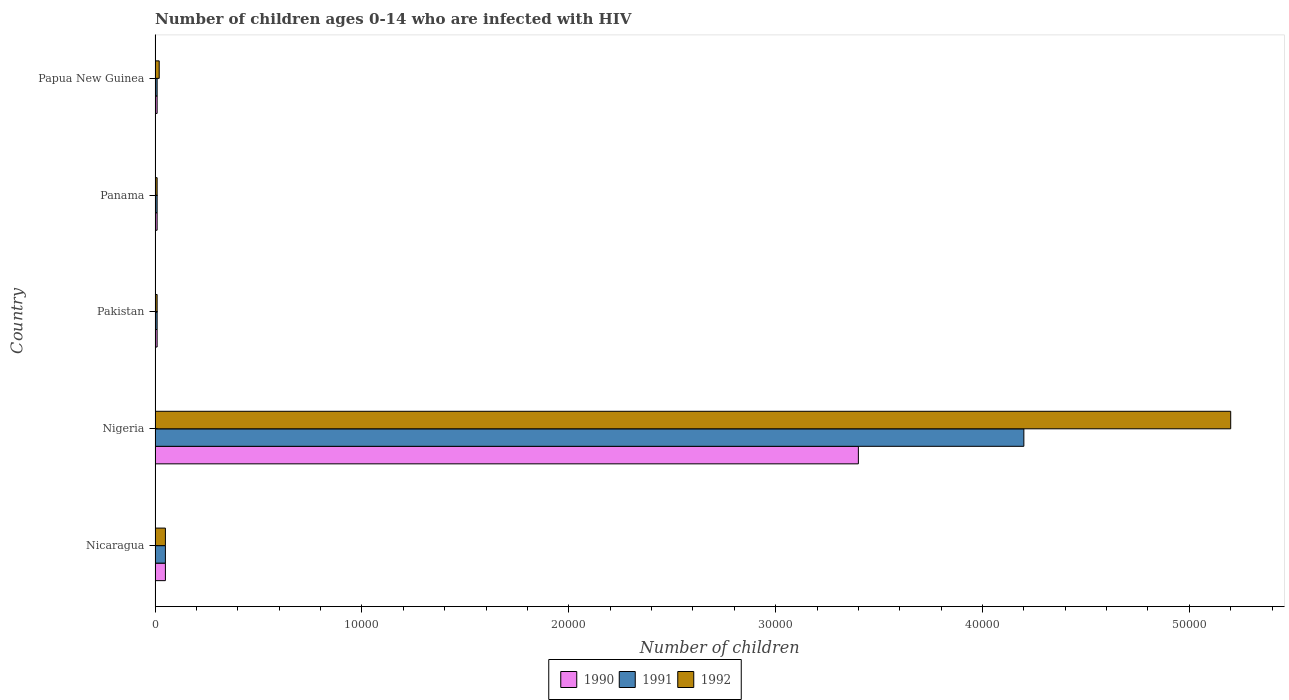Are the number of bars on each tick of the Y-axis equal?
Offer a terse response. Yes. How many bars are there on the 5th tick from the bottom?
Offer a very short reply. 3. What is the label of the 1st group of bars from the top?
Your answer should be compact. Papua New Guinea. What is the number of HIV infected children in 1992 in Panama?
Offer a terse response. 100. Across all countries, what is the maximum number of HIV infected children in 1992?
Your response must be concise. 5.20e+04. Across all countries, what is the minimum number of HIV infected children in 1990?
Your answer should be very brief. 100. In which country was the number of HIV infected children in 1990 maximum?
Provide a short and direct response. Nigeria. In which country was the number of HIV infected children in 1992 minimum?
Offer a terse response. Pakistan. What is the total number of HIV infected children in 1992 in the graph?
Your answer should be compact. 5.29e+04. What is the difference between the number of HIV infected children in 1991 in Nicaragua and that in Nigeria?
Keep it short and to the point. -4.15e+04. What is the difference between the number of HIV infected children in 1991 in Nicaragua and the number of HIV infected children in 1990 in Panama?
Offer a very short reply. 400. What is the average number of HIV infected children in 1991 per country?
Ensure brevity in your answer.  8560. What is the difference between the number of HIV infected children in 1992 and number of HIV infected children in 1991 in Nicaragua?
Ensure brevity in your answer.  0. In how many countries, is the number of HIV infected children in 1990 greater than 32000 ?
Keep it short and to the point. 1. What is the difference between the highest and the second highest number of HIV infected children in 1990?
Give a very brief answer. 3.35e+04. What is the difference between the highest and the lowest number of HIV infected children in 1992?
Keep it short and to the point. 5.19e+04. Is the sum of the number of HIV infected children in 1990 in Nicaragua and Pakistan greater than the maximum number of HIV infected children in 1991 across all countries?
Ensure brevity in your answer.  No. What does the 1st bar from the top in Nigeria represents?
Provide a short and direct response. 1992. What does the 2nd bar from the bottom in Papua New Guinea represents?
Provide a succinct answer. 1991. Is it the case that in every country, the sum of the number of HIV infected children in 1992 and number of HIV infected children in 1990 is greater than the number of HIV infected children in 1991?
Provide a succinct answer. Yes. How many countries are there in the graph?
Your response must be concise. 5. What is the difference between two consecutive major ticks on the X-axis?
Your answer should be compact. 10000. Are the values on the major ticks of X-axis written in scientific E-notation?
Provide a short and direct response. No. Does the graph contain any zero values?
Your response must be concise. No. Does the graph contain grids?
Keep it short and to the point. No. How many legend labels are there?
Give a very brief answer. 3. What is the title of the graph?
Provide a short and direct response. Number of children ages 0-14 who are infected with HIV. Does "2015" appear as one of the legend labels in the graph?
Your answer should be very brief. No. What is the label or title of the X-axis?
Offer a very short reply. Number of children. What is the label or title of the Y-axis?
Provide a succinct answer. Country. What is the Number of children of 1990 in Nicaragua?
Offer a very short reply. 500. What is the Number of children in 1991 in Nicaragua?
Keep it short and to the point. 500. What is the Number of children of 1990 in Nigeria?
Make the answer very short. 3.40e+04. What is the Number of children in 1991 in Nigeria?
Your answer should be very brief. 4.20e+04. What is the Number of children of 1992 in Nigeria?
Give a very brief answer. 5.20e+04. What is the Number of children of 1992 in Pakistan?
Provide a succinct answer. 100. What is the Number of children in 1991 in Panama?
Ensure brevity in your answer.  100. What is the Number of children of 1992 in Panama?
Give a very brief answer. 100. What is the Number of children in 1990 in Papua New Guinea?
Offer a very short reply. 100. What is the Number of children in 1992 in Papua New Guinea?
Give a very brief answer. 200. Across all countries, what is the maximum Number of children in 1990?
Give a very brief answer. 3.40e+04. Across all countries, what is the maximum Number of children of 1991?
Provide a succinct answer. 4.20e+04. Across all countries, what is the maximum Number of children in 1992?
Offer a terse response. 5.20e+04. Across all countries, what is the minimum Number of children in 1992?
Keep it short and to the point. 100. What is the total Number of children in 1990 in the graph?
Keep it short and to the point. 3.48e+04. What is the total Number of children of 1991 in the graph?
Offer a very short reply. 4.28e+04. What is the total Number of children in 1992 in the graph?
Provide a short and direct response. 5.29e+04. What is the difference between the Number of children in 1990 in Nicaragua and that in Nigeria?
Offer a very short reply. -3.35e+04. What is the difference between the Number of children in 1991 in Nicaragua and that in Nigeria?
Make the answer very short. -4.15e+04. What is the difference between the Number of children of 1992 in Nicaragua and that in Nigeria?
Provide a succinct answer. -5.15e+04. What is the difference between the Number of children in 1991 in Nicaragua and that in Panama?
Your response must be concise. 400. What is the difference between the Number of children of 1992 in Nicaragua and that in Panama?
Give a very brief answer. 400. What is the difference between the Number of children in 1990 in Nicaragua and that in Papua New Guinea?
Offer a terse response. 400. What is the difference between the Number of children in 1991 in Nicaragua and that in Papua New Guinea?
Offer a very short reply. 400. What is the difference between the Number of children of 1992 in Nicaragua and that in Papua New Guinea?
Provide a short and direct response. 300. What is the difference between the Number of children in 1990 in Nigeria and that in Pakistan?
Offer a very short reply. 3.39e+04. What is the difference between the Number of children of 1991 in Nigeria and that in Pakistan?
Provide a short and direct response. 4.19e+04. What is the difference between the Number of children in 1992 in Nigeria and that in Pakistan?
Offer a terse response. 5.19e+04. What is the difference between the Number of children in 1990 in Nigeria and that in Panama?
Provide a short and direct response. 3.39e+04. What is the difference between the Number of children in 1991 in Nigeria and that in Panama?
Make the answer very short. 4.19e+04. What is the difference between the Number of children in 1992 in Nigeria and that in Panama?
Offer a very short reply. 5.19e+04. What is the difference between the Number of children of 1990 in Nigeria and that in Papua New Guinea?
Your answer should be very brief. 3.39e+04. What is the difference between the Number of children in 1991 in Nigeria and that in Papua New Guinea?
Ensure brevity in your answer.  4.19e+04. What is the difference between the Number of children of 1992 in Nigeria and that in Papua New Guinea?
Your answer should be very brief. 5.18e+04. What is the difference between the Number of children in 1991 in Pakistan and that in Panama?
Offer a very short reply. 0. What is the difference between the Number of children in 1991 in Pakistan and that in Papua New Guinea?
Ensure brevity in your answer.  0. What is the difference between the Number of children of 1992 in Pakistan and that in Papua New Guinea?
Ensure brevity in your answer.  -100. What is the difference between the Number of children in 1990 in Panama and that in Papua New Guinea?
Your answer should be compact. 0. What is the difference between the Number of children in 1991 in Panama and that in Papua New Guinea?
Offer a very short reply. 0. What is the difference between the Number of children of 1992 in Panama and that in Papua New Guinea?
Keep it short and to the point. -100. What is the difference between the Number of children in 1990 in Nicaragua and the Number of children in 1991 in Nigeria?
Provide a short and direct response. -4.15e+04. What is the difference between the Number of children in 1990 in Nicaragua and the Number of children in 1992 in Nigeria?
Your response must be concise. -5.15e+04. What is the difference between the Number of children in 1991 in Nicaragua and the Number of children in 1992 in Nigeria?
Provide a succinct answer. -5.15e+04. What is the difference between the Number of children in 1990 in Nicaragua and the Number of children in 1991 in Pakistan?
Make the answer very short. 400. What is the difference between the Number of children in 1990 in Nicaragua and the Number of children in 1992 in Pakistan?
Your answer should be compact. 400. What is the difference between the Number of children of 1990 in Nicaragua and the Number of children of 1992 in Papua New Guinea?
Keep it short and to the point. 300. What is the difference between the Number of children in 1991 in Nicaragua and the Number of children in 1992 in Papua New Guinea?
Ensure brevity in your answer.  300. What is the difference between the Number of children in 1990 in Nigeria and the Number of children in 1991 in Pakistan?
Ensure brevity in your answer.  3.39e+04. What is the difference between the Number of children of 1990 in Nigeria and the Number of children of 1992 in Pakistan?
Your answer should be compact. 3.39e+04. What is the difference between the Number of children of 1991 in Nigeria and the Number of children of 1992 in Pakistan?
Make the answer very short. 4.19e+04. What is the difference between the Number of children in 1990 in Nigeria and the Number of children in 1991 in Panama?
Your answer should be very brief. 3.39e+04. What is the difference between the Number of children in 1990 in Nigeria and the Number of children in 1992 in Panama?
Make the answer very short. 3.39e+04. What is the difference between the Number of children of 1991 in Nigeria and the Number of children of 1992 in Panama?
Provide a succinct answer. 4.19e+04. What is the difference between the Number of children of 1990 in Nigeria and the Number of children of 1991 in Papua New Guinea?
Your answer should be very brief. 3.39e+04. What is the difference between the Number of children in 1990 in Nigeria and the Number of children in 1992 in Papua New Guinea?
Your answer should be compact. 3.38e+04. What is the difference between the Number of children of 1991 in Nigeria and the Number of children of 1992 in Papua New Guinea?
Keep it short and to the point. 4.18e+04. What is the difference between the Number of children of 1991 in Pakistan and the Number of children of 1992 in Panama?
Your response must be concise. 0. What is the difference between the Number of children in 1990 in Pakistan and the Number of children in 1992 in Papua New Guinea?
Offer a very short reply. -100. What is the difference between the Number of children of 1991 in Pakistan and the Number of children of 1992 in Papua New Guinea?
Your answer should be compact. -100. What is the difference between the Number of children of 1990 in Panama and the Number of children of 1992 in Papua New Guinea?
Ensure brevity in your answer.  -100. What is the difference between the Number of children in 1991 in Panama and the Number of children in 1992 in Papua New Guinea?
Your response must be concise. -100. What is the average Number of children in 1990 per country?
Make the answer very short. 6960. What is the average Number of children in 1991 per country?
Provide a short and direct response. 8560. What is the average Number of children of 1992 per country?
Ensure brevity in your answer.  1.06e+04. What is the difference between the Number of children of 1990 and Number of children of 1991 in Nicaragua?
Make the answer very short. 0. What is the difference between the Number of children of 1991 and Number of children of 1992 in Nicaragua?
Your answer should be very brief. 0. What is the difference between the Number of children of 1990 and Number of children of 1991 in Nigeria?
Your response must be concise. -8000. What is the difference between the Number of children in 1990 and Number of children in 1992 in Nigeria?
Make the answer very short. -1.80e+04. What is the difference between the Number of children in 1991 and Number of children in 1992 in Nigeria?
Ensure brevity in your answer.  -10000. What is the difference between the Number of children of 1990 and Number of children of 1991 in Panama?
Offer a very short reply. 0. What is the difference between the Number of children of 1990 and Number of children of 1992 in Panama?
Offer a very short reply. 0. What is the difference between the Number of children in 1991 and Number of children in 1992 in Panama?
Your response must be concise. 0. What is the difference between the Number of children in 1990 and Number of children in 1991 in Papua New Guinea?
Make the answer very short. 0. What is the difference between the Number of children of 1990 and Number of children of 1992 in Papua New Guinea?
Ensure brevity in your answer.  -100. What is the difference between the Number of children of 1991 and Number of children of 1992 in Papua New Guinea?
Your answer should be very brief. -100. What is the ratio of the Number of children of 1990 in Nicaragua to that in Nigeria?
Ensure brevity in your answer.  0.01. What is the ratio of the Number of children in 1991 in Nicaragua to that in Nigeria?
Offer a very short reply. 0.01. What is the ratio of the Number of children of 1992 in Nicaragua to that in Nigeria?
Make the answer very short. 0.01. What is the ratio of the Number of children of 1990 in Nicaragua to that in Pakistan?
Ensure brevity in your answer.  5. What is the ratio of the Number of children of 1991 in Nicaragua to that in Pakistan?
Keep it short and to the point. 5. What is the ratio of the Number of children in 1990 in Nicaragua to that in Papua New Guinea?
Your response must be concise. 5. What is the ratio of the Number of children of 1992 in Nicaragua to that in Papua New Guinea?
Ensure brevity in your answer.  2.5. What is the ratio of the Number of children in 1990 in Nigeria to that in Pakistan?
Provide a succinct answer. 340. What is the ratio of the Number of children in 1991 in Nigeria to that in Pakistan?
Give a very brief answer. 420. What is the ratio of the Number of children of 1992 in Nigeria to that in Pakistan?
Make the answer very short. 520. What is the ratio of the Number of children of 1990 in Nigeria to that in Panama?
Offer a very short reply. 340. What is the ratio of the Number of children in 1991 in Nigeria to that in Panama?
Provide a short and direct response. 420. What is the ratio of the Number of children in 1992 in Nigeria to that in Panama?
Make the answer very short. 520. What is the ratio of the Number of children in 1990 in Nigeria to that in Papua New Guinea?
Offer a terse response. 340. What is the ratio of the Number of children in 1991 in Nigeria to that in Papua New Guinea?
Your answer should be compact. 420. What is the ratio of the Number of children of 1992 in Nigeria to that in Papua New Guinea?
Provide a succinct answer. 260. What is the ratio of the Number of children in 1990 in Pakistan to that in Panama?
Your response must be concise. 1. What is the ratio of the Number of children of 1991 in Pakistan to that in Panama?
Your answer should be compact. 1. What is the ratio of the Number of children in 1990 in Pakistan to that in Papua New Guinea?
Provide a succinct answer. 1. What is the ratio of the Number of children in 1990 in Panama to that in Papua New Guinea?
Provide a succinct answer. 1. What is the ratio of the Number of children of 1991 in Panama to that in Papua New Guinea?
Offer a terse response. 1. What is the ratio of the Number of children of 1992 in Panama to that in Papua New Guinea?
Offer a very short reply. 0.5. What is the difference between the highest and the second highest Number of children in 1990?
Your answer should be compact. 3.35e+04. What is the difference between the highest and the second highest Number of children of 1991?
Keep it short and to the point. 4.15e+04. What is the difference between the highest and the second highest Number of children in 1992?
Your answer should be compact. 5.15e+04. What is the difference between the highest and the lowest Number of children in 1990?
Offer a terse response. 3.39e+04. What is the difference between the highest and the lowest Number of children of 1991?
Offer a very short reply. 4.19e+04. What is the difference between the highest and the lowest Number of children of 1992?
Your answer should be very brief. 5.19e+04. 